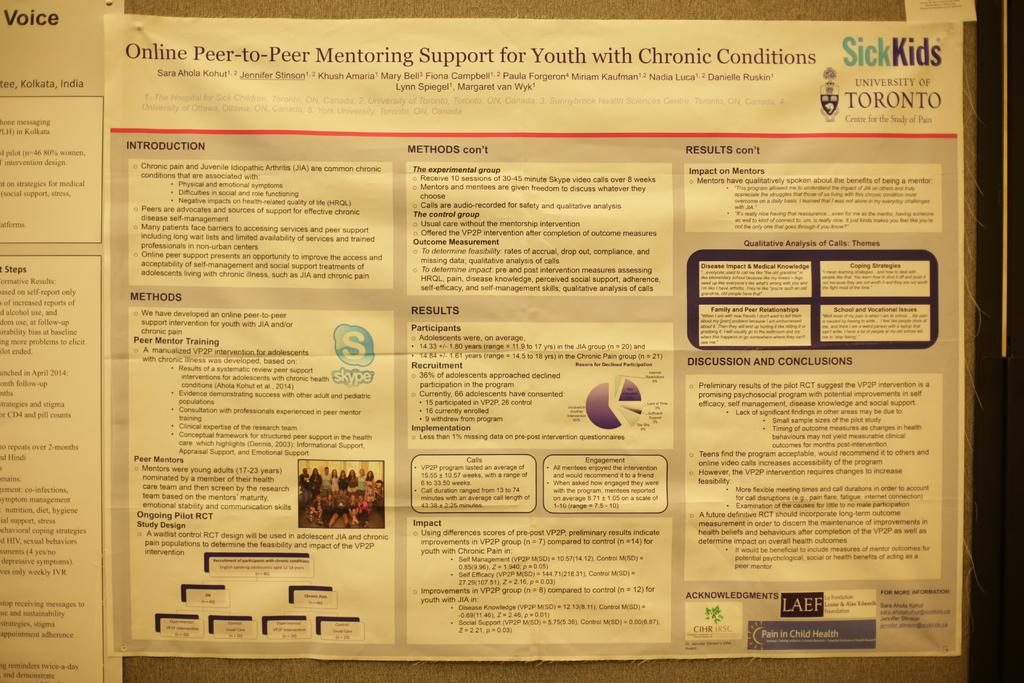<image>
Relay a brief, clear account of the picture shown. A flyer by the University of Toronto advertises online peer-to-peer mentoring support. 